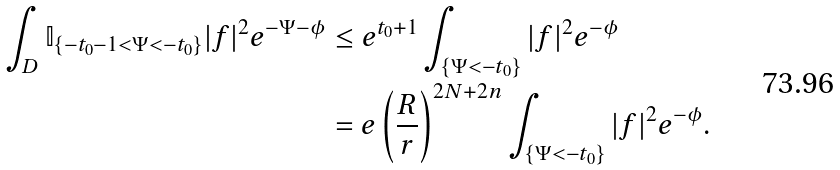Convert formula to latex. <formula><loc_0><loc_0><loc_500><loc_500>\int _ { D } \mathbb { I } _ { \{ - t _ { 0 } - 1 < \Psi < - t _ { 0 } \} } | f | ^ { 2 } e ^ { - \Psi - \phi } & \leq e ^ { t _ { 0 } + 1 } \int _ { \{ \Psi < - t _ { 0 } \} } | f | ^ { 2 } e ^ { - \phi } \\ & = e \left ( \frac { R } { r } \right ) ^ { 2 N + 2 n } \int _ { \{ \Psi < - t _ { 0 } \} } | f | ^ { 2 } e ^ { - \phi } .</formula> 